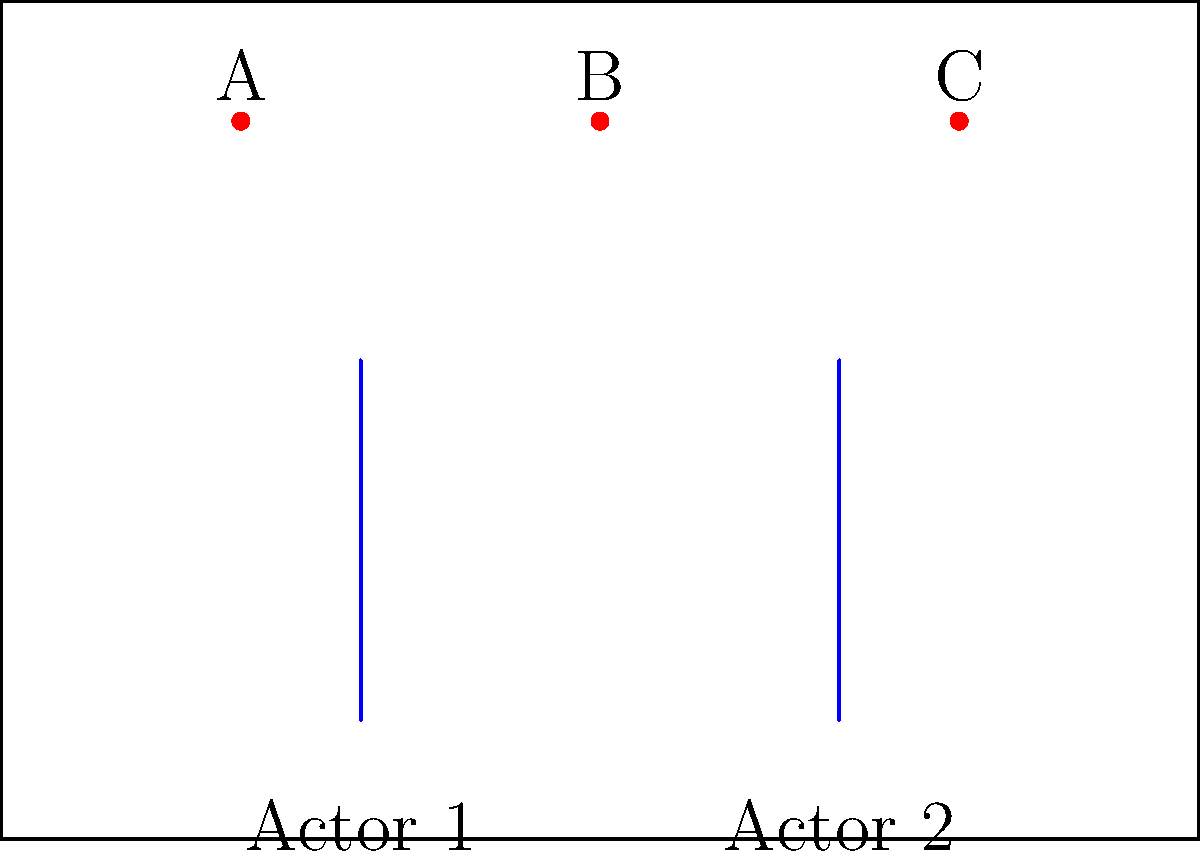Based on your experience in set lighting, which light source (A, B, or C) should be adjusted to create the most balanced illumination for both actors in this scene? To determine the optimal lighting setup, we need to consider the following steps:

1. Assess the position of the actors:
   Actor 1 is at x = 3
   Actor 2 is at x = 7

2. Evaluate the position of the light sources:
   Light A is at x = 2
   Light B is at x = 5
   Light C is at x = 8

3. Calculate the distance between each light and the actors:
   Light A to Actor 1: |2 - 3| = 1
   Light A to Actor 2: |2 - 7| = 5
   Light B to Actor 1: |5 - 3| = 2
   Light B to Actor 2: |5 - 7| = 2
   Light C to Actor 1: |8 - 3| = 5
   Light C to Actor 2: |8 - 7| = 1

4. Analyze the balance:
   Light A favors Actor 1
   Light C favors Actor 2
   Light B is equidistant from both actors

5. Conclusion:
   Light B (x = 5) is the most centrally located and provides the most balanced illumination for both actors. Adjusting this light will have the most significant impact on overall scene lighting balance.
Answer: Light B 